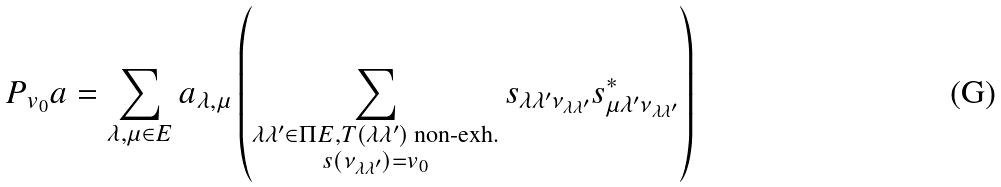Convert formula to latex. <formula><loc_0><loc_0><loc_500><loc_500>P _ { v _ { 0 } } a = \sum _ { \lambda , \mu \in E } a _ { \lambda , \mu } \left ( \sum _ { \substack { \lambda \lambda ^ { \prime } \in \Pi E , T ( \lambda \lambda ^ { \prime } ) \text { non-exh.} \\ s ( \nu _ { \lambda \lambda ^ { \prime } } ) = v _ { 0 } } } s _ { \lambda \lambda ^ { \prime } \nu _ { \lambda \lambda ^ { \prime } } } s ^ { * } _ { \mu \lambda ^ { \prime } \nu _ { \lambda \lambda ^ { \prime } } } \right )</formula> 